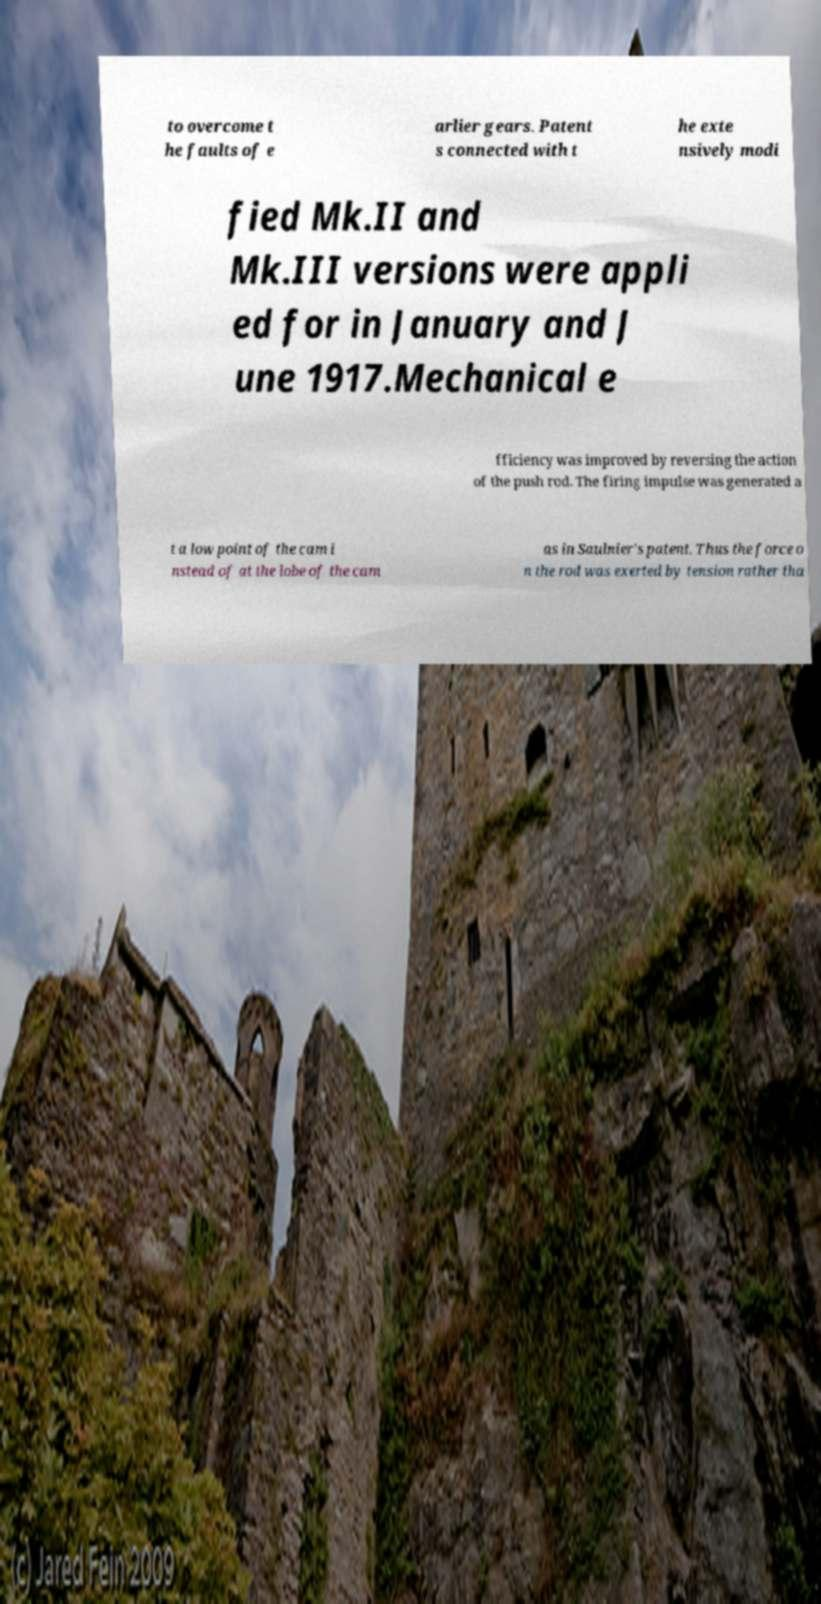What messages or text are displayed in this image? I need them in a readable, typed format. to overcome t he faults of e arlier gears. Patent s connected with t he exte nsively modi fied Mk.II and Mk.III versions were appli ed for in January and J une 1917.Mechanical e fficiency was improved by reversing the action of the push rod. The firing impulse was generated a t a low point of the cam i nstead of at the lobe of the cam as in Saulnier's patent. Thus the force o n the rod was exerted by tension rather tha 